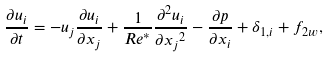Convert formula to latex. <formula><loc_0><loc_0><loc_500><loc_500>\frac { \partial { u _ { i } } } { \partial { t } } = - u _ { j } \frac { \partial { u _ { i } } } { \partial { x _ { j } } } + \frac { 1 } { R e ^ { * } } \frac { \partial ^ { 2 } { u _ { i } } } { \partial { x _ { j } } ^ { 2 } } - \frac { \partial { p } } { \partial { x _ { i } } } + \delta _ { 1 , i } + f _ { 2 w } ,</formula> 